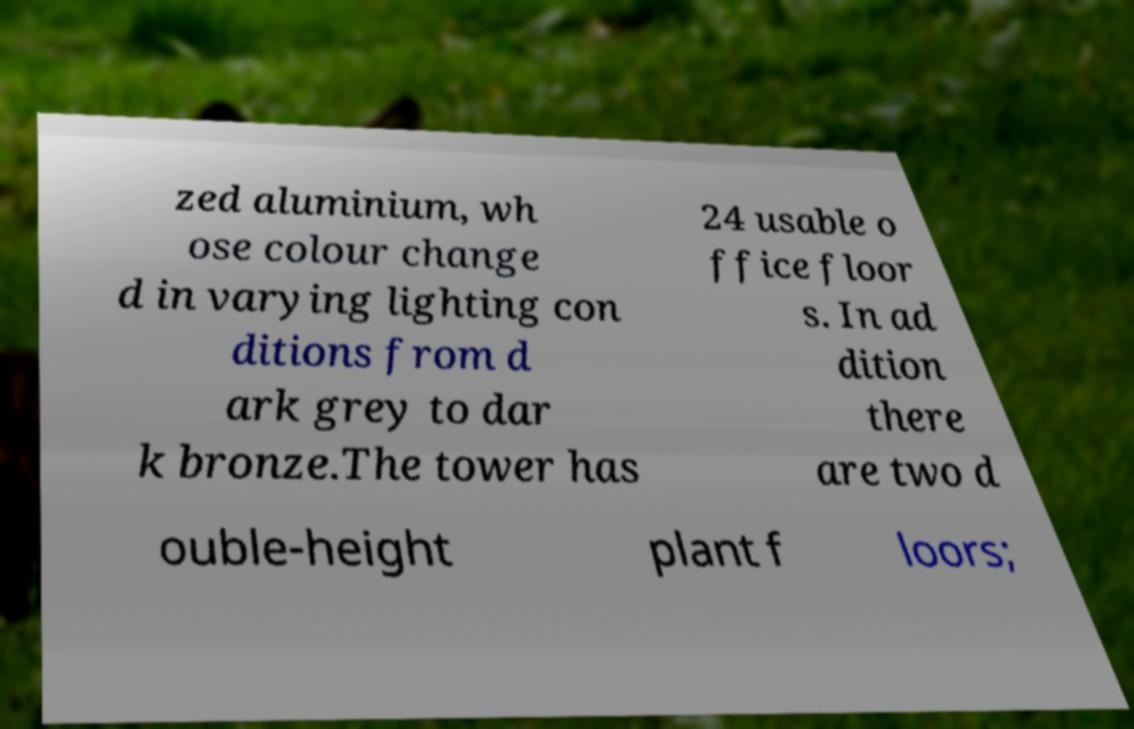Can you read and provide the text displayed in the image?This photo seems to have some interesting text. Can you extract and type it out for me? zed aluminium, wh ose colour change d in varying lighting con ditions from d ark grey to dar k bronze.The tower has 24 usable o ffice floor s. In ad dition there are two d ouble-height plant f loors; 